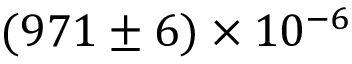<formula> <loc_0><loc_0><loc_500><loc_500>( 9 7 1 \pm 6 ) \times 1 0 ^ { - 6 }</formula> 